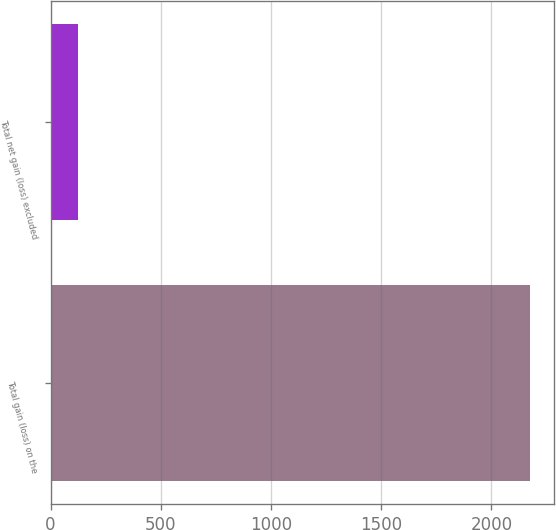<chart> <loc_0><loc_0><loc_500><loc_500><bar_chart><fcel>Total gain (loss) on the<fcel>Total net gain (loss) excluded<nl><fcel>2176.6<fcel>125<nl></chart> 